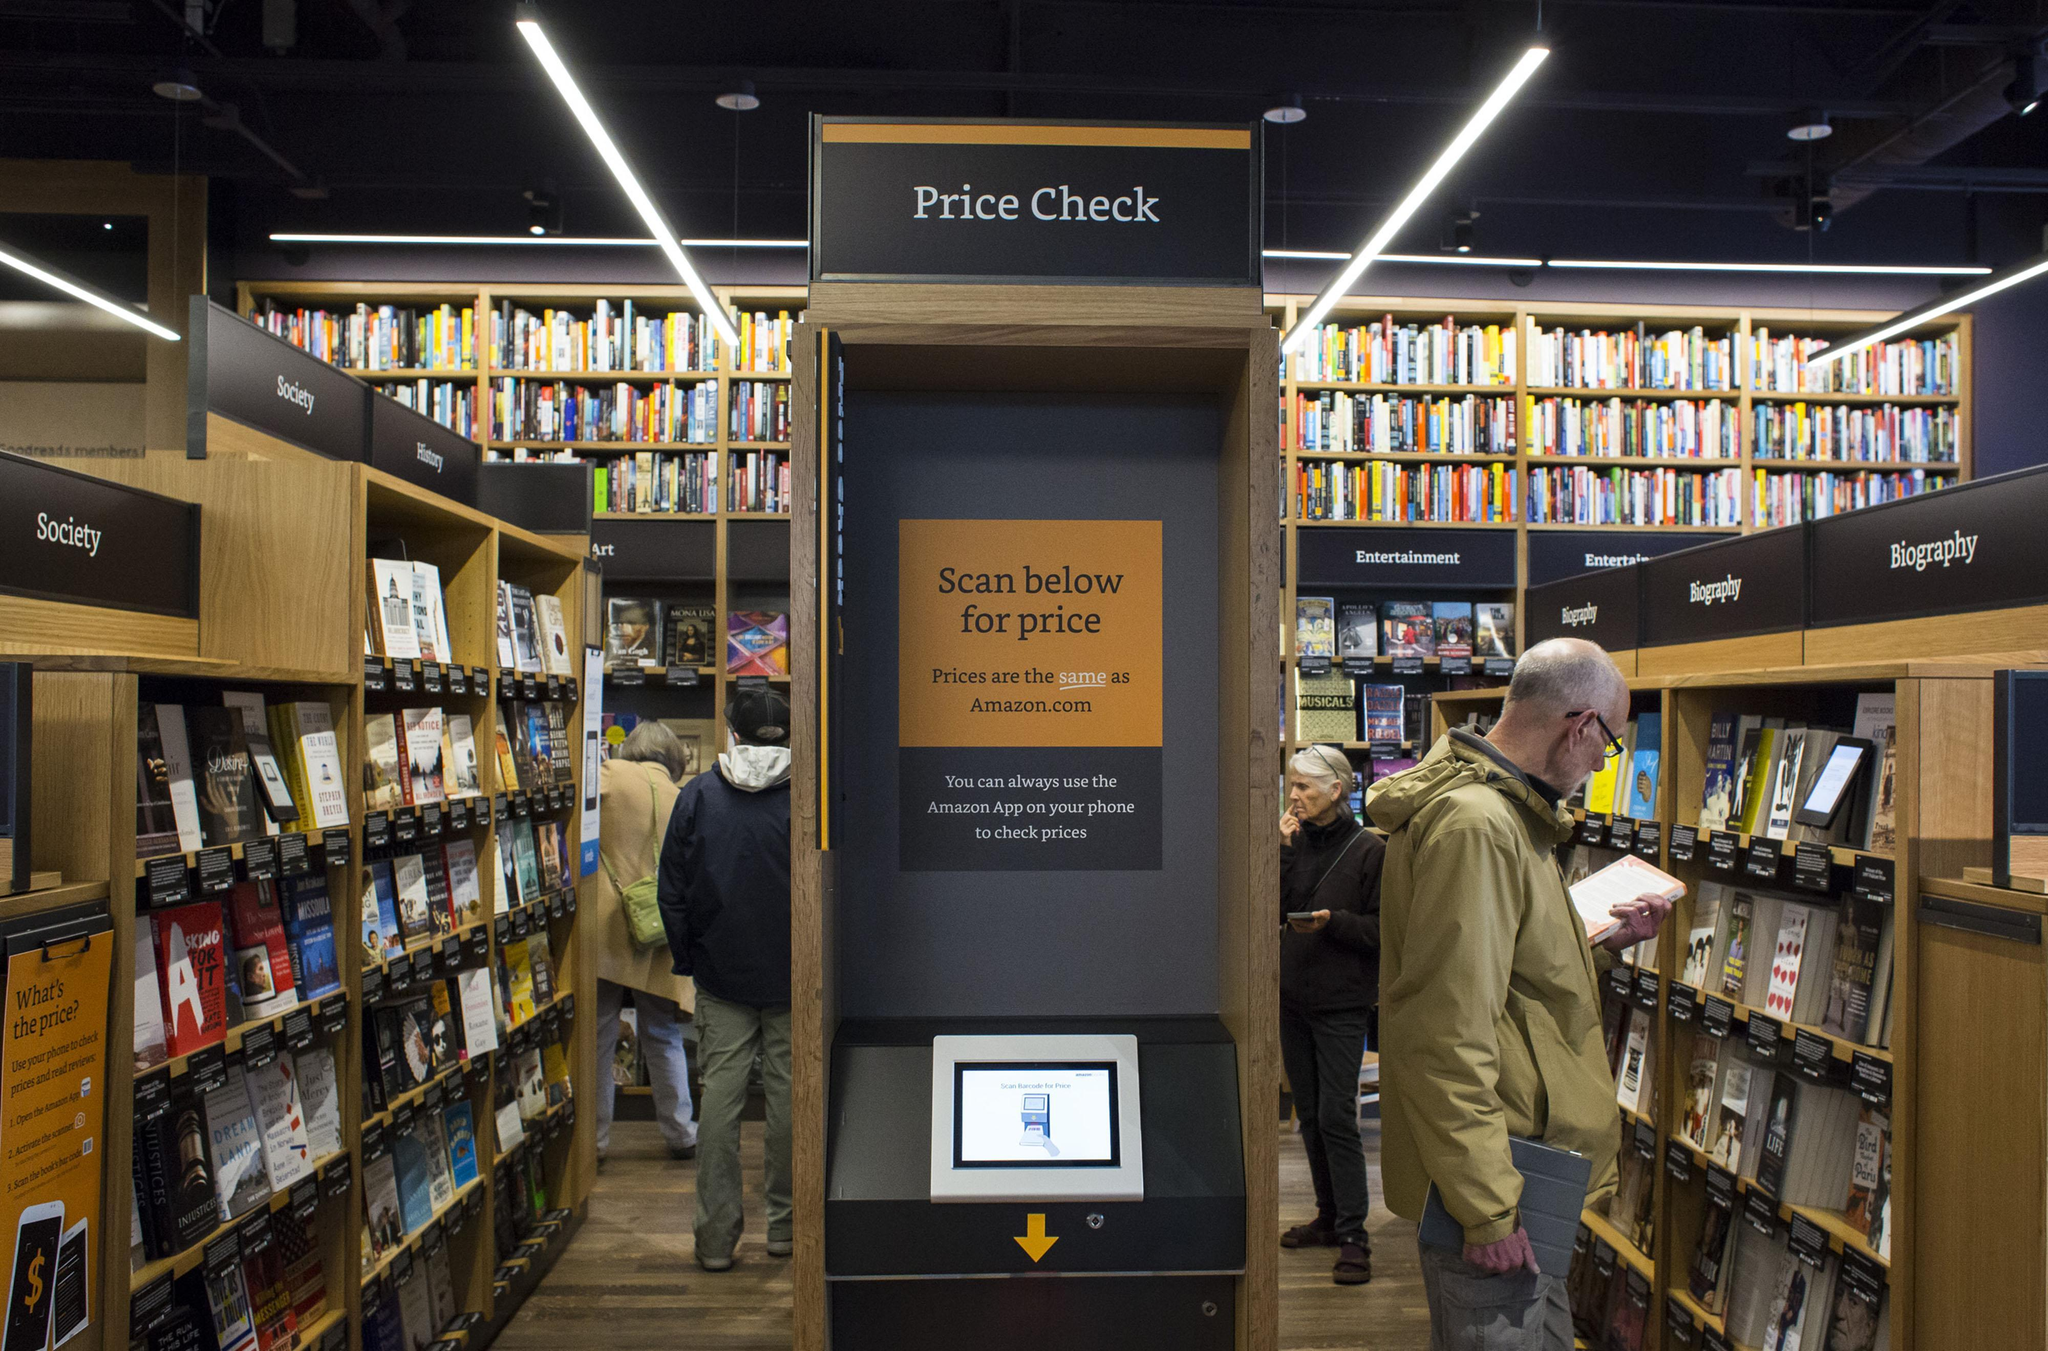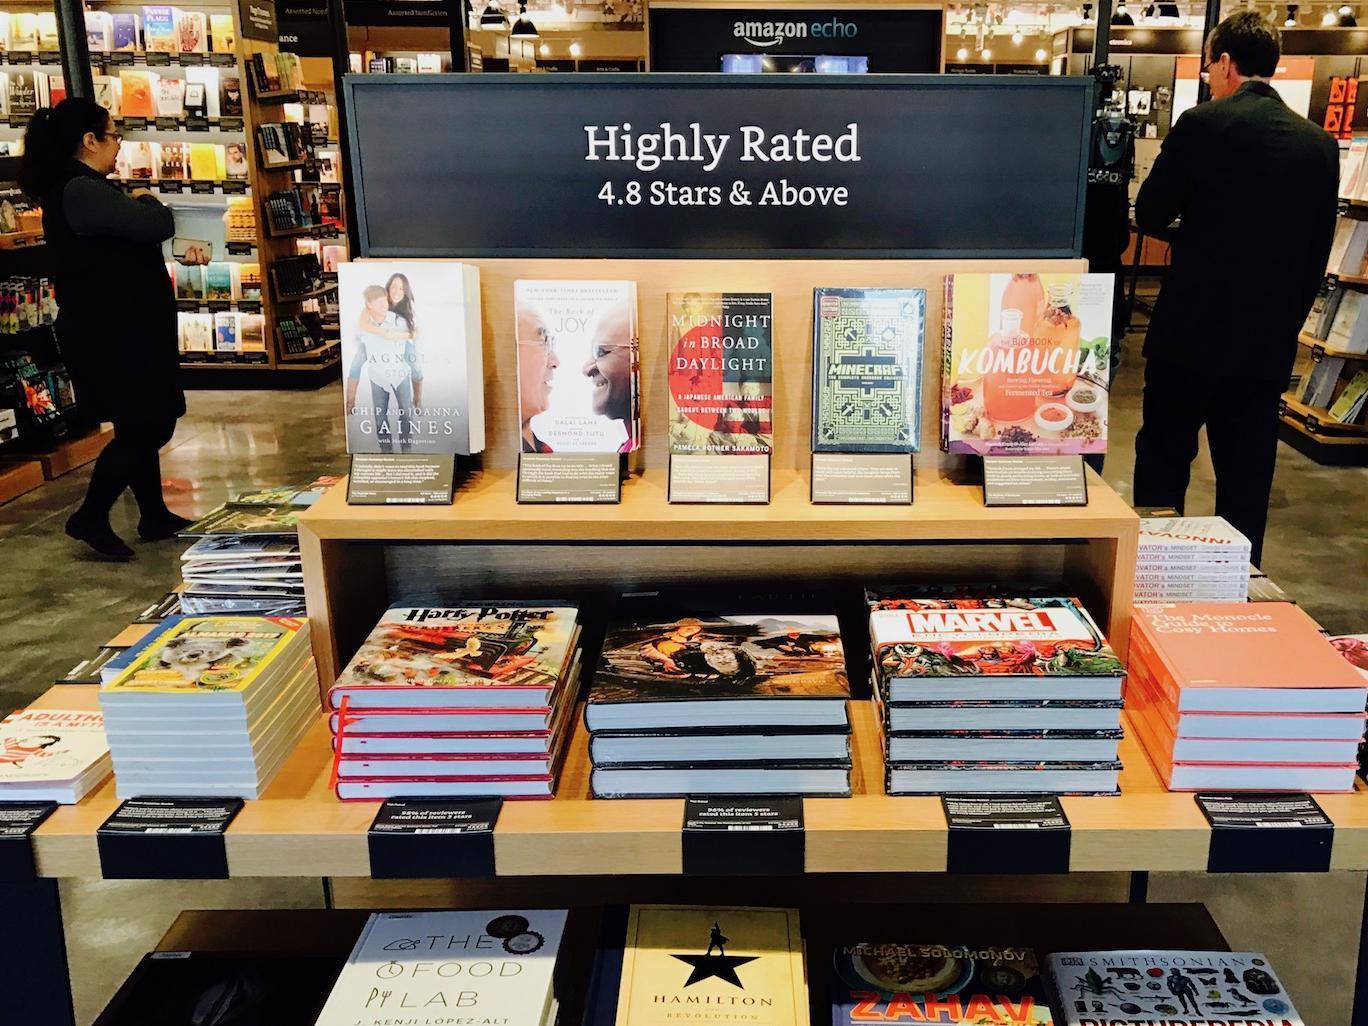The first image is the image on the left, the second image is the image on the right. Considering the images on both sides, is "A person wearing black is standing on each side of one image, with a tiered stand of books topped with a horizontal black sign between the people." valid? Answer yes or no. Yes. The first image is the image on the left, the second image is the image on the right. For the images displayed, is the sentence "There are at least 5 stack of 4 books on the lower part of the display with the bottom of each book facing forward." factually correct? Answer yes or no. Yes. 